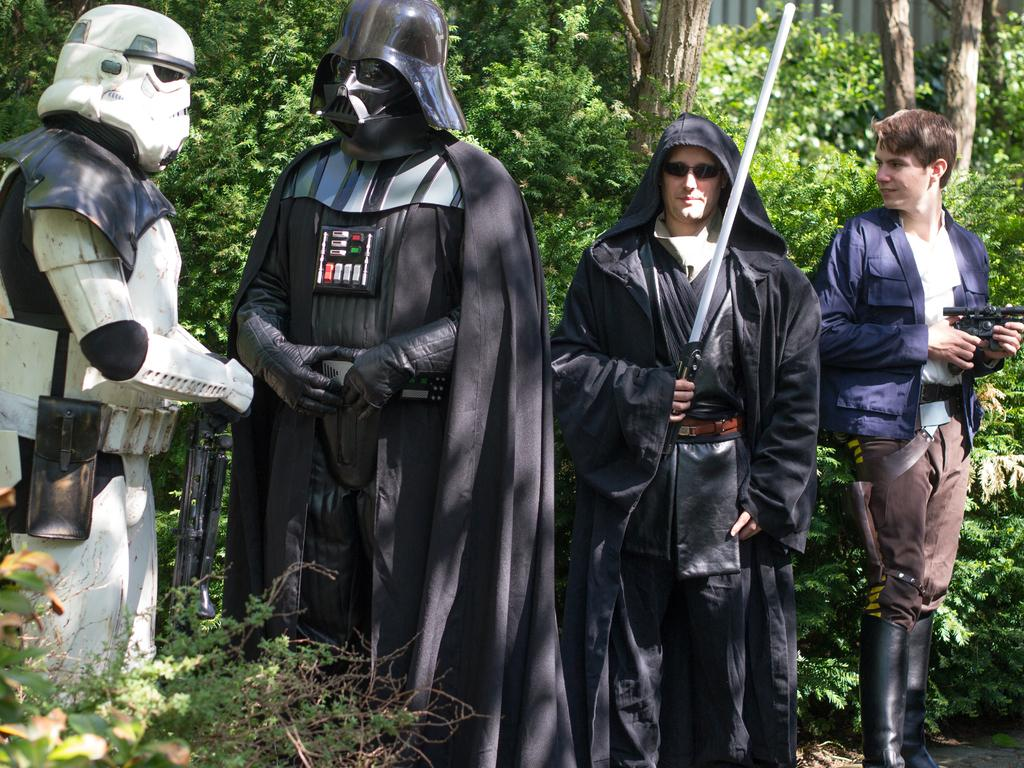How many people are present in the image? There are two persons standing on the right side of the image. What are the people on the left side of the image wearing? The two persons on the left side of the image appear to be wearing costumes. What can be seen in the background of the image? There are trees visible in the background of the image. What type of beef is being served at the table in the image? There is no table or beef present in the image. Can you tell me how many giraffes are visible in the image? There are no giraffes visible in the image. 